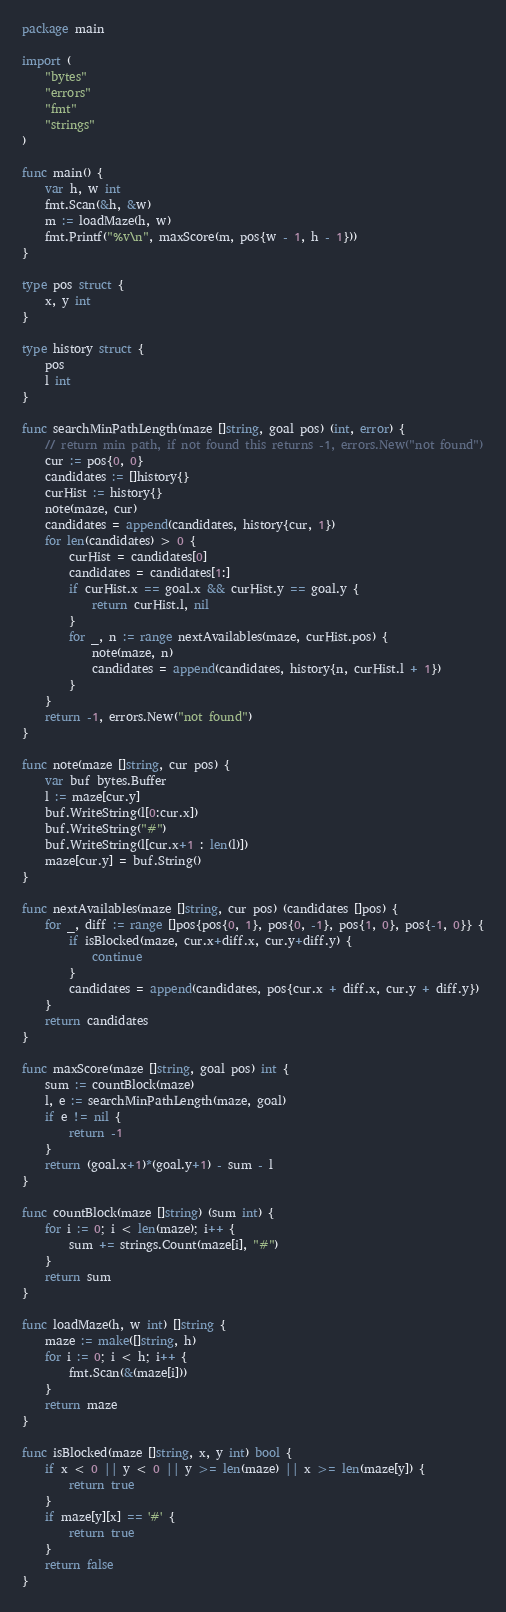<code> <loc_0><loc_0><loc_500><loc_500><_Go_>package main

import (
	"bytes"
	"errors"
	"fmt"
	"strings"
)

func main() {
	var h, w int
	fmt.Scan(&h, &w)
	m := loadMaze(h, w)
	fmt.Printf("%v\n", maxScore(m, pos{w - 1, h - 1}))
}

type pos struct {
	x, y int
}

type history struct {
	pos
	l int
}

func searchMinPathLength(maze []string, goal pos) (int, error) {
	// return min path, if not found this returns -1, errors.New("not found")
	cur := pos{0, 0}
	candidates := []history{}
	curHist := history{}
	note(maze, cur)
	candidates = append(candidates, history{cur, 1})
	for len(candidates) > 0 {
		curHist = candidates[0]
		candidates = candidates[1:]
		if curHist.x == goal.x && curHist.y == goal.y {
			return curHist.l, nil
		}
		for _, n := range nextAvailables(maze, curHist.pos) {
			note(maze, n)
			candidates = append(candidates, history{n, curHist.l + 1})
		}
	}
	return -1, errors.New("not found")
}

func note(maze []string, cur pos) {
	var buf bytes.Buffer
	l := maze[cur.y]
	buf.WriteString(l[0:cur.x])
	buf.WriteString("#")
	buf.WriteString(l[cur.x+1 : len(l)])
	maze[cur.y] = buf.String()
}

func nextAvailables(maze []string, cur pos) (candidates []pos) {
	for _, diff := range []pos{pos{0, 1}, pos{0, -1}, pos{1, 0}, pos{-1, 0}} {
		if isBlocked(maze, cur.x+diff.x, cur.y+diff.y) {
			continue
		}
		candidates = append(candidates, pos{cur.x + diff.x, cur.y + diff.y})
	}
	return candidates
}

func maxScore(maze []string, goal pos) int {
	sum := countBlock(maze)
	l, e := searchMinPathLength(maze, goal)
	if e != nil {
		return -1
	}
	return (goal.x+1)*(goal.y+1) - sum - l
}

func countBlock(maze []string) (sum int) {
	for i := 0; i < len(maze); i++ {
		sum += strings.Count(maze[i], "#")
	}
	return sum
}

func loadMaze(h, w int) []string {
	maze := make([]string, h)
	for i := 0; i < h; i++ {
		fmt.Scan(&(maze[i]))
	}
	return maze
}

func isBlocked(maze []string, x, y int) bool {
	if x < 0 || y < 0 || y >= len(maze) || x >= len(maze[y]) {
		return true
	}
	if maze[y][x] == '#' {
		return true
	}
	return false
}
</code> 